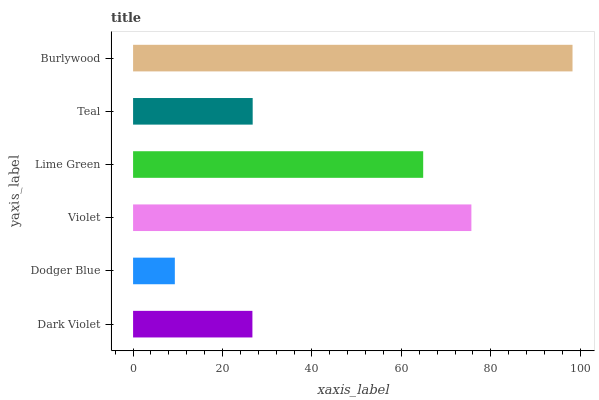Is Dodger Blue the minimum?
Answer yes or no. Yes. Is Burlywood the maximum?
Answer yes or no. Yes. Is Violet the minimum?
Answer yes or no. No. Is Violet the maximum?
Answer yes or no. No. Is Violet greater than Dodger Blue?
Answer yes or no. Yes. Is Dodger Blue less than Violet?
Answer yes or no. Yes. Is Dodger Blue greater than Violet?
Answer yes or no. No. Is Violet less than Dodger Blue?
Answer yes or no. No. Is Lime Green the high median?
Answer yes or no. Yes. Is Teal the low median?
Answer yes or no. Yes. Is Teal the high median?
Answer yes or no. No. Is Burlywood the low median?
Answer yes or no. No. 